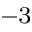Convert formula to latex. <formula><loc_0><loc_0><loc_500><loc_500>^ { - 3 }</formula> 